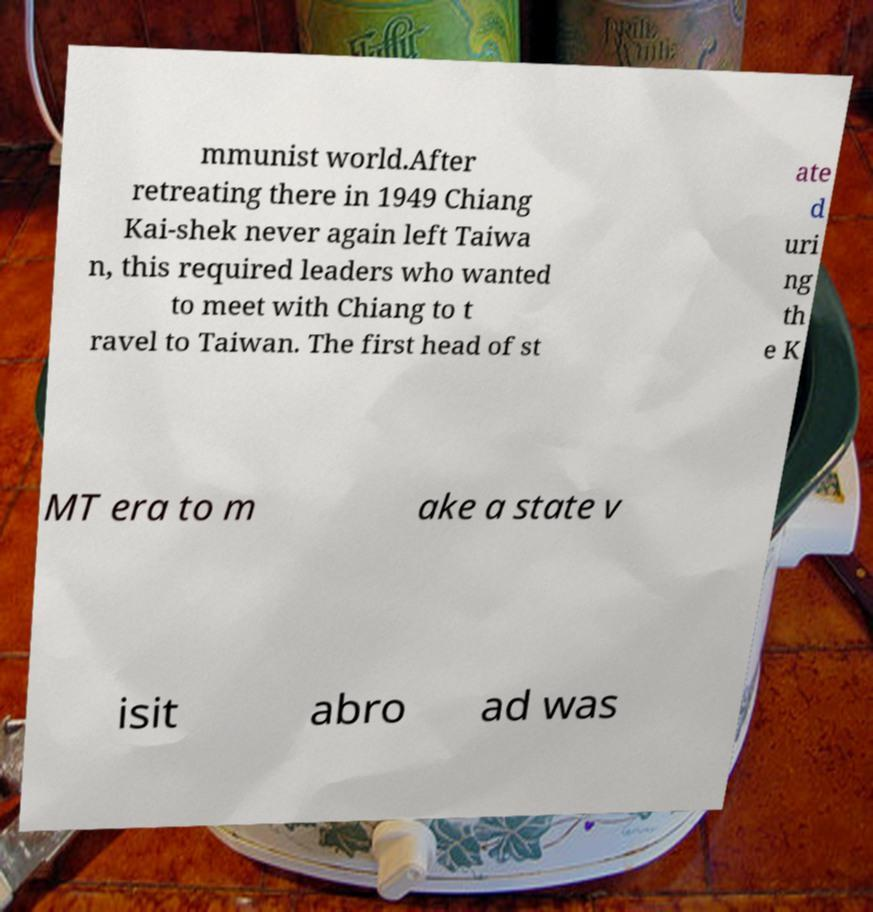Could you extract and type out the text from this image? mmunist world.After retreating there in 1949 Chiang Kai-shek never again left Taiwa n, this required leaders who wanted to meet with Chiang to t ravel to Taiwan. The first head of st ate d uri ng th e K MT era to m ake a state v isit abro ad was 